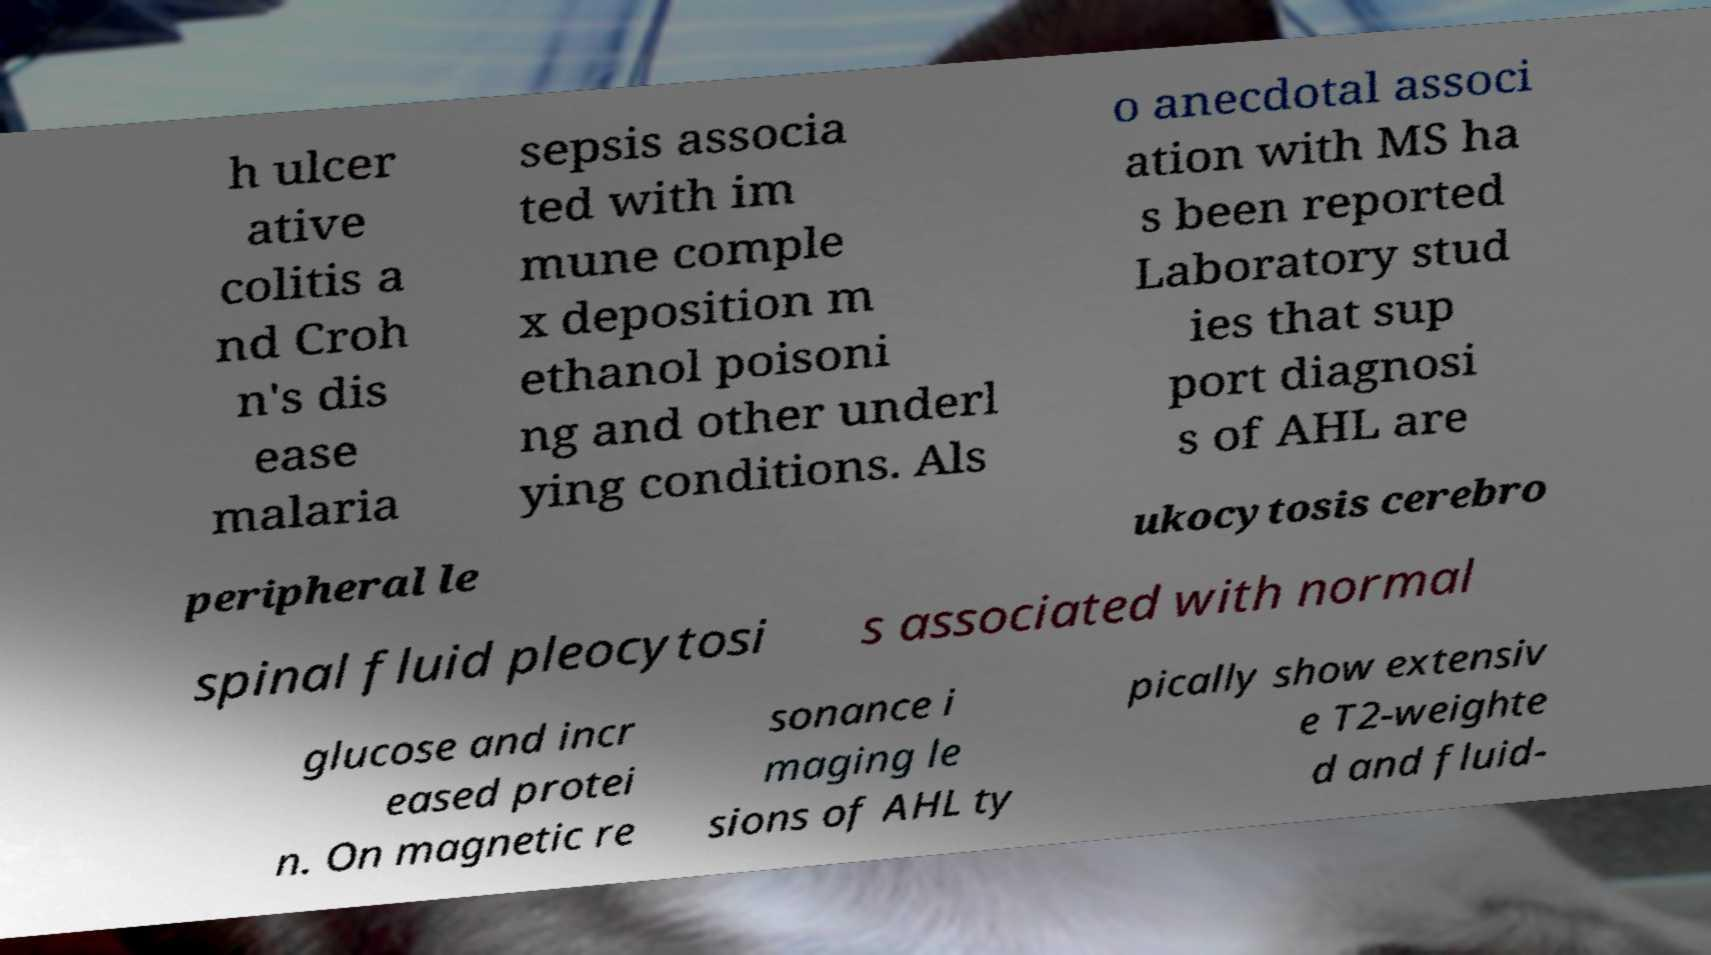There's text embedded in this image that I need extracted. Can you transcribe it verbatim? h ulcer ative colitis a nd Croh n's dis ease malaria sepsis associa ted with im mune comple x deposition m ethanol poisoni ng and other underl ying conditions. Als o anecdotal associ ation with MS ha s been reported Laboratory stud ies that sup port diagnosi s of AHL are peripheral le ukocytosis cerebro spinal fluid pleocytosi s associated with normal glucose and incr eased protei n. On magnetic re sonance i maging le sions of AHL ty pically show extensiv e T2-weighte d and fluid- 